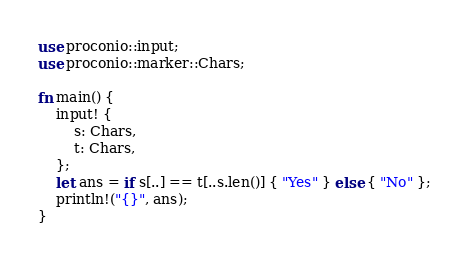Convert code to text. <code><loc_0><loc_0><loc_500><loc_500><_Rust_>use proconio::input;
use proconio::marker::Chars;

fn main() {
    input! {
        s: Chars,
        t: Chars,
    };
    let ans = if s[..] == t[..s.len()] { "Yes" } else { "No" };
    println!("{}", ans);
}
</code> 